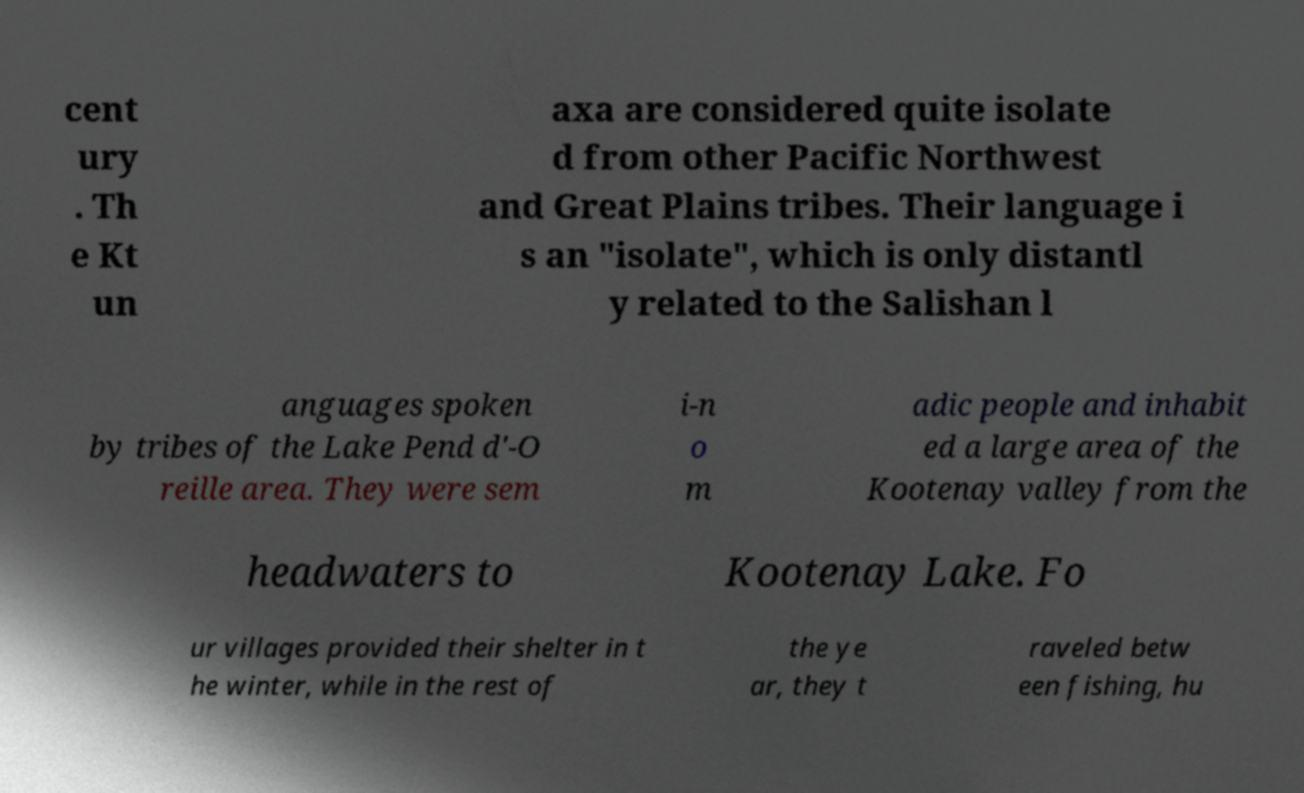Can you accurately transcribe the text from the provided image for me? cent ury . Th e Kt un axa are considered quite isolate d from other Pacific Northwest and Great Plains tribes. Their language i s an "isolate", which is only distantl y related to the Salishan l anguages spoken by tribes of the Lake Pend d'-O reille area. They were sem i-n o m adic people and inhabit ed a large area of the Kootenay valley from the headwaters to Kootenay Lake. Fo ur villages provided their shelter in t he winter, while in the rest of the ye ar, they t raveled betw een fishing, hu 